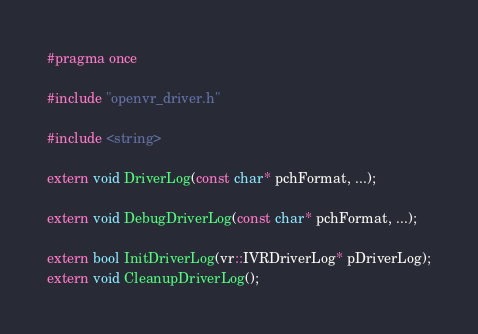<code> <loc_0><loc_0><loc_500><loc_500><_C_>#pragma once

#include "openvr_driver.h"

#include <string>

extern void DriverLog(const char* pchFormat, ...);

extern void DebugDriverLog(const char* pchFormat, ...);

extern bool InitDriverLog(vr::IVRDriverLog* pDriverLog);
extern void CleanupDriverLog();
</code> 